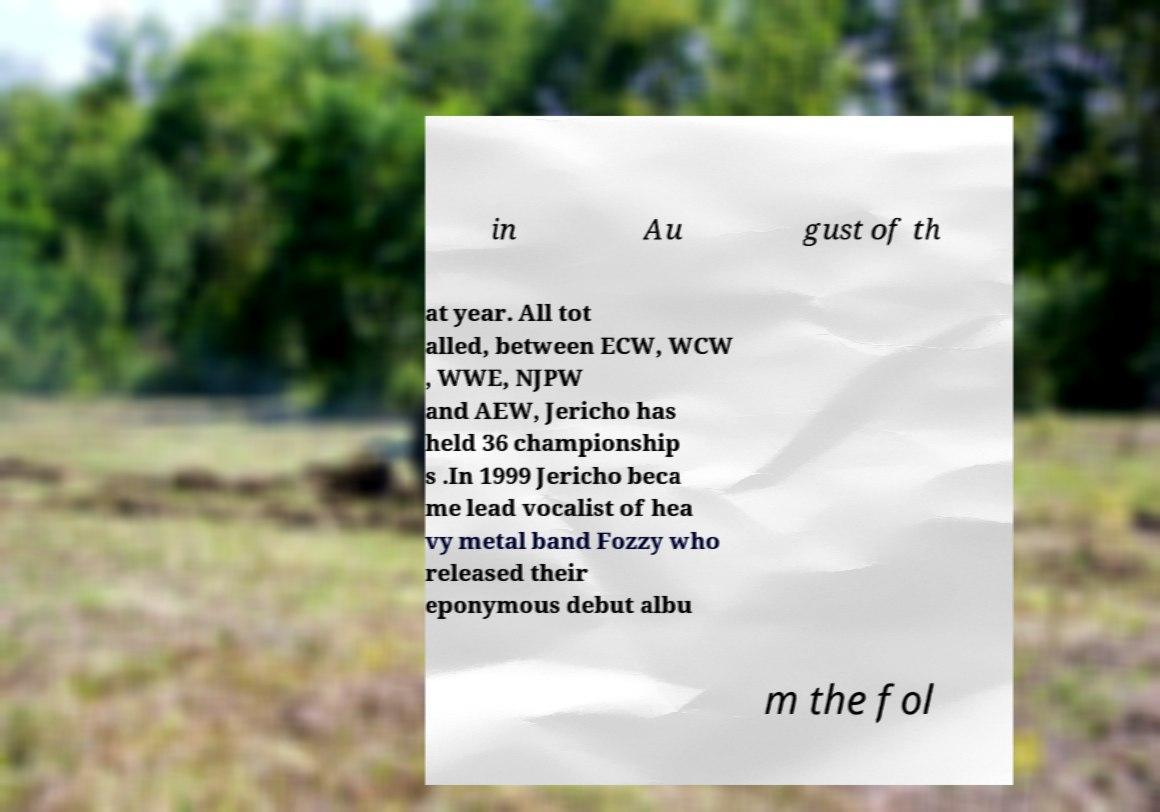I need the written content from this picture converted into text. Can you do that? in Au gust of th at year. All tot alled, between ECW, WCW , WWE, NJPW and AEW, Jericho has held 36 championship s .In 1999 Jericho beca me lead vocalist of hea vy metal band Fozzy who released their eponymous debut albu m the fol 